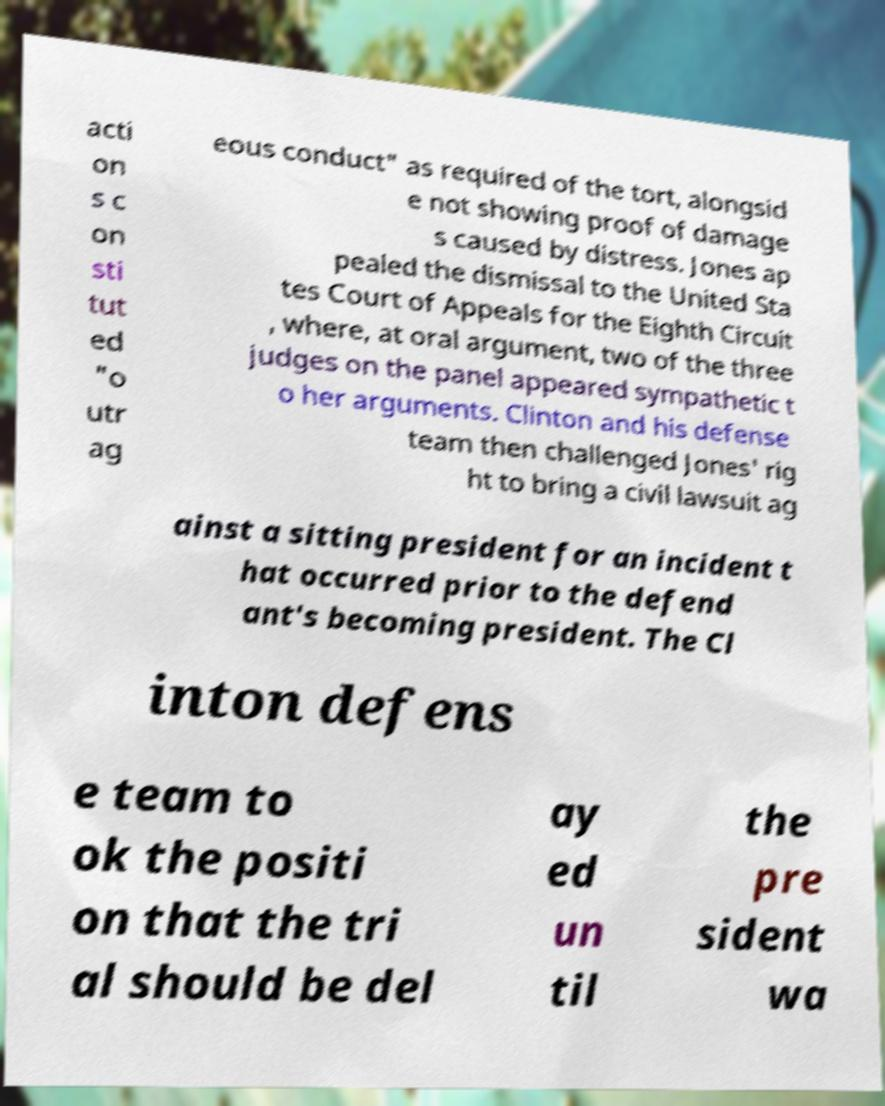Can you accurately transcribe the text from the provided image for me? acti on s c on sti tut ed "o utr ag eous conduct" as required of the tort, alongsid e not showing proof of damage s caused by distress. Jones ap pealed the dismissal to the United Sta tes Court of Appeals for the Eighth Circuit , where, at oral argument, two of the three judges on the panel appeared sympathetic t o her arguments. Clinton and his defense team then challenged Jones' rig ht to bring a civil lawsuit ag ainst a sitting president for an incident t hat occurred prior to the defend ant's becoming president. The Cl inton defens e team to ok the positi on that the tri al should be del ay ed un til the pre sident wa 